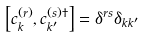Convert formula to latex. <formula><loc_0><loc_0><loc_500><loc_500>\left [ c ^ { ( r ) } _ { k } , c ^ { ( s ) \dag } _ { k ^ { \prime } } \right ] = \delta ^ { r s } \delta _ { k k ^ { \prime } }</formula> 